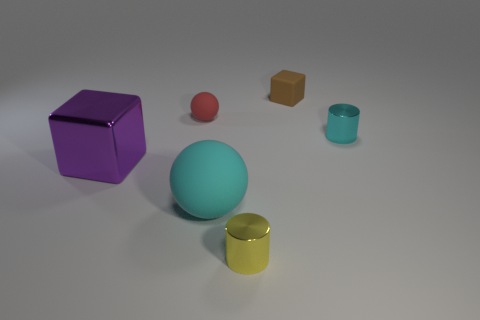Add 4 small yellow things. How many objects exist? 10 Subtract all cylinders. How many objects are left? 4 Add 5 brown metallic cylinders. How many brown metallic cylinders exist? 5 Subtract 0 gray balls. How many objects are left? 6 Subtract all small yellow cubes. Subtract all brown matte objects. How many objects are left? 5 Add 6 small spheres. How many small spheres are left? 7 